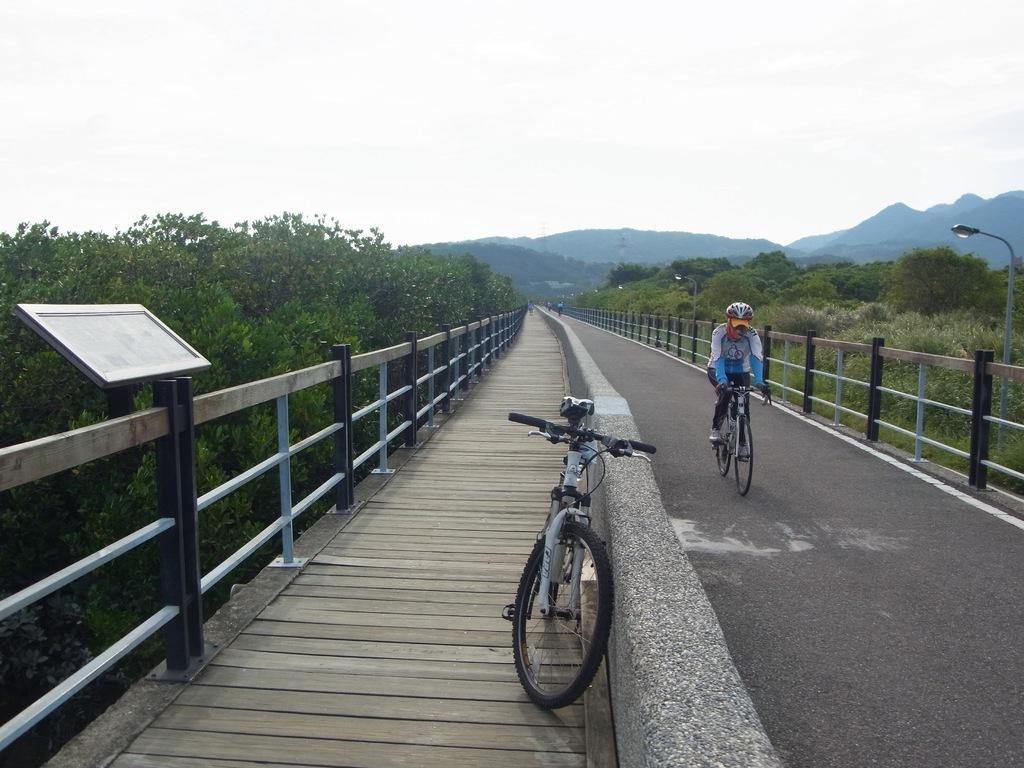How would you summarize this image in a sentence or two? In this picture we can see a person wore a helmet, riding a bicycle on the road, fences, trees, pole, bicycle on the footpath, mountains, some objects and in the background we can see the sky. 